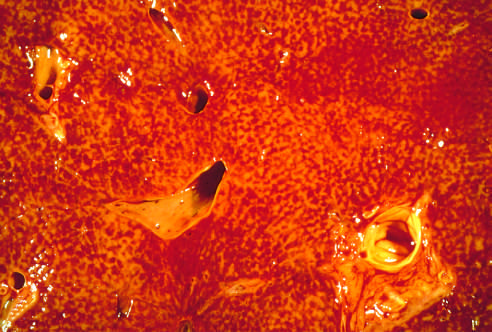what is the cut liver section notable for?
Answer the question using a single word or phrase. The variegated mottled red appearance 